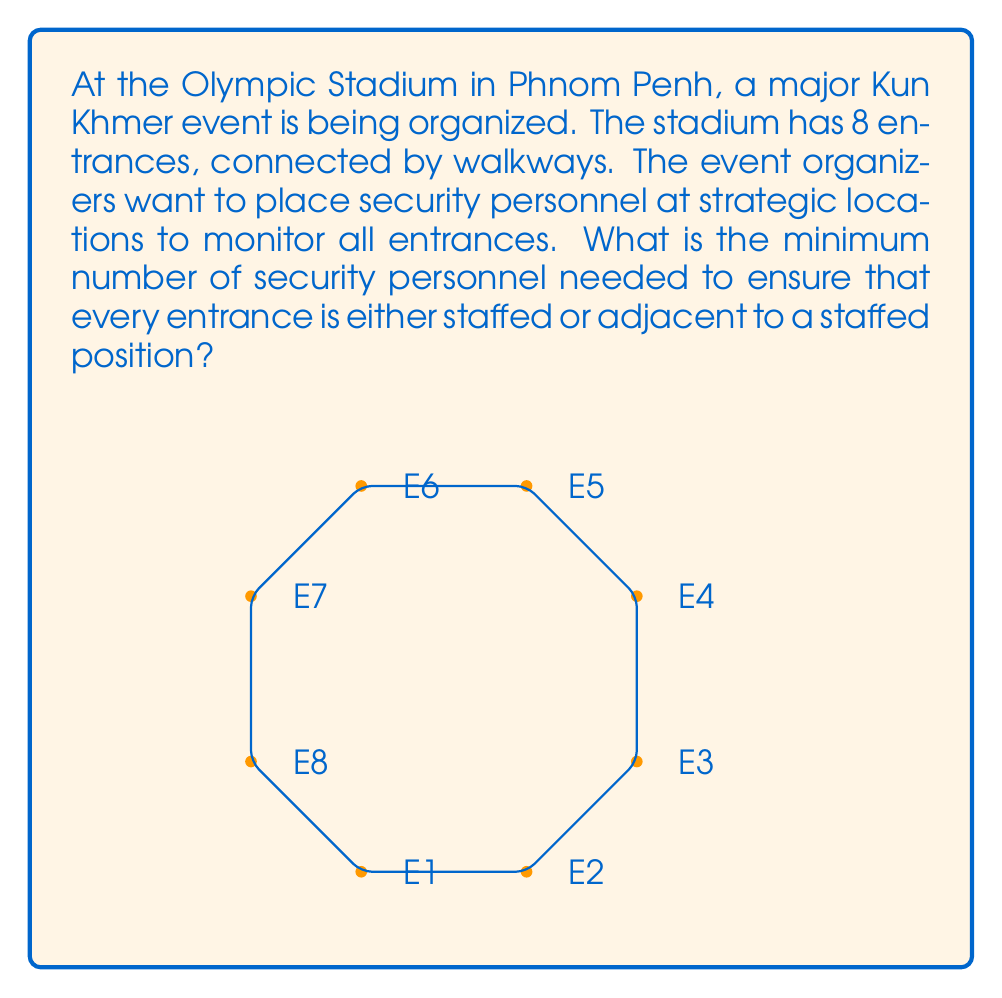Teach me how to tackle this problem. This problem can be solved using graph theory, specifically the concept of dominating sets in graphs. 

1) First, we model the stadium layout as a graph:
   - Each entrance is a vertex.
   - Walkways between entrances are edges.

2) The graph is circular, with 8 vertices representing the 8 entrances.

3) We need to find the minimum dominating set of this graph. A dominating set is a subset of vertices such that every vertex not in the subset is adjacent to at least one vertex in the subset.

4) For a cycle graph with 8 vertices, the minimum dominating set size is $\left\lceil\frac{n}{3}\right\rceil$, where $n$ is the number of vertices.

5) Calculation:
   $$\left\lceil\frac{8}{3}\right\rceil = \left\lceil2.67\right\rceil = 3$$

6) Verification:
   - Place security at entrances E1, E4, and E7.
   - E2 and E8 are covered by E1.
   - E3 and E5 are covered by E4.
   - E6 is covered by E7.

Therefore, the minimum number of security personnel needed is 3.
Answer: 3 security personnel 